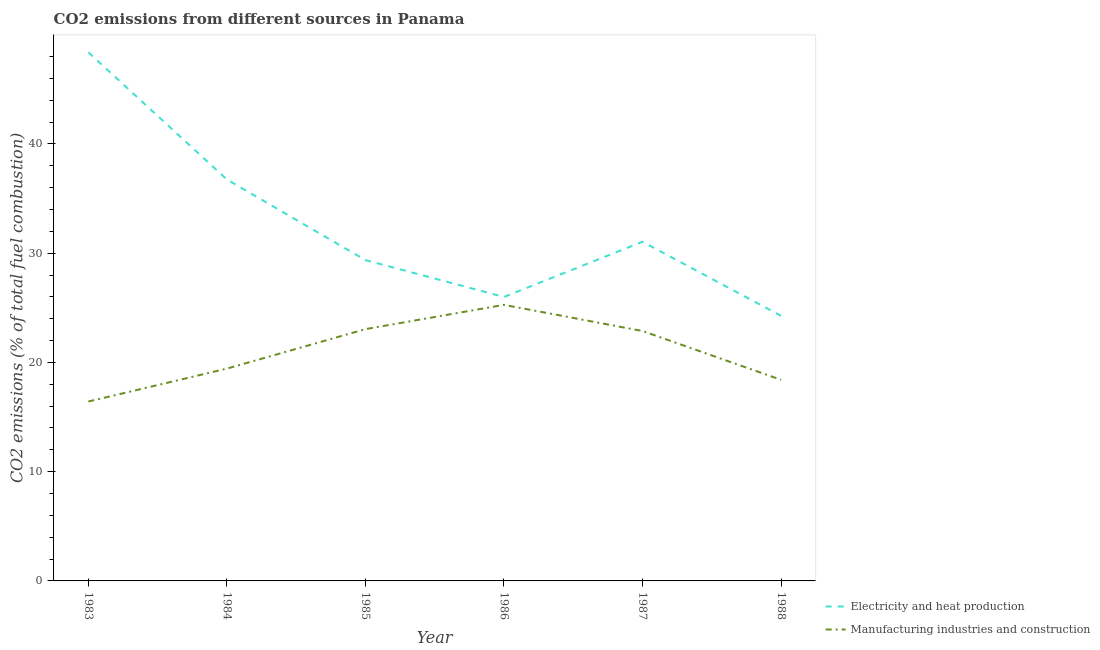Is the number of lines equal to the number of legend labels?
Provide a short and direct response. Yes. What is the co2 emissions due to manufacturing industries in 1987?
Provide a short and direct response. 22.88. Across all years, what is the maximum co2 emissions due to manufacturing industries?
Make the answer very short. 25.27. Across all years, what is the minimum co2 emissions due to manufacturing industries?
Offer a very short reply. 16.42. In which year was the co2 emissions due to electricity and heat production minimum?
Make the answer very short. 1988. What is the total co2 emissions due to electricity and heat production in the graph?
Your response must be concise. 195.81. What is the difference between the co2 emissions due to electricity and heat production in 1984 and that in 1988?
Provide a succinct answer. 12.48. What is the difference between the co2 emissions due to electricity and heat production in 1988 and the co2 emissions due to manufacturing industries in 1987?
Keep it short and to the point. 1.39. What is the average co2 emissions due to manufacturing industries per year?
Ensure brevity in your answer.  20.91. In the year 1986, what is the difference between the co2 emissions due to manufacturing industries and co2 emissions due to electricity and heat production?
Ensure brevity in your answer.  -0.72. What is the ratio of the co2 emissions due to manufacturing industries in 1987 to that in 1988?
Offer a very short reply. 1.24. Is the co2 emissions due to manufacturing industries in 1983 less than that in 1988?
Your answer should be compact. Yes. What is the difference between the highest and the second highest co2 emissions due to manufacturing industries?
Offer a very short reply. 2.22. What is the difference between the highest and the lowest co2 emissions due to electricity and heat production?
Offer a terse response. 24.12. In how many years, is the co2 emissions due to electricity and heat production greater than the average co2 emissions due to electricity and heat production taken over all years?
Ensure brevity in your answer.  2. How many years are there in the graph?
Offer a terse response. 6. Does the graph contain any zero values?
Your response must be concise. No. Does the graph contain grids?
Keep it short and to the point. No. How many legend labels are there?
Ensure brevity in your answer.  2. What is the title of the graph?
Offer a terse response. CO2 emissions from different sources in Panama. What is the label or title of the Y-axis?
Give a very brief answer. CO2 emissions (% of total fuel combustion). What is the CO2 emissions (% of total fuel combustion) of Electricity and heat production in 1983?
Provide a short and direct response. 48.39. What is the CO2 emissions (% of total fuel combustion) in Manufacturing industries and construction in 1983?
Your answer should be compact. 16.42. What is the CO2 emissions (% of total fuel combustion) of Electricity and heat production in 1984?
Make the answer very short. 36.75. What is the CO2 emissions (% of total fuel combustion) in Manufacturing industries and construction in 1984?
Your response must be concise. 19.43. What is the CO2 emissions (% of total fuel combustion) in Electricity and heat production in 1985?
Provide a succinct answer. 29.37. What is the CO2 emissions (% of total fuel combustion) of Manufacturing industries and construction in 1985?
Give a very brief answer. 23.05. What is the CO2 emissions (% of total fuel combustion) of Electricity and heat production in 1986?
Ensure brevity in your answer.  25.99. What is the CO2 emissions (% of total fuel combustion) of Manufacturing industries and construction in 1986?
Offer a terse response. 25.27. What is the CO2 emissions (% of total fuel combustion) in Electricity and heat production in 1987?
Offer a terse response. 31.05. What is the CO2 emissions (% of total fuel combustion) in Manufacturing industries and construction in 1987?
Offer a very short reply. 22.88. What is the CO2 emissions (% of total fuel combustion) of Electricity and heat production in 1988?
Your answer should be very brief. 24.27. What is the CO2 emissions (% of total fuel combustion) of Manufacturing industries and construction in 1988?
Keep it short and to the point. 18.41. Across all years, what is the maximum CO2 emissions (% of total fuel combustion) of Electricity and heat production?
Ensure brevity in your answer.  48.39. Across all years, what is the maximum CO2 emissions (% of total fuel combustion) in Manufacturing industries and construction?
Provide a short and direct response. 25.27. Across all years, what is the minimum CO2 emissions (% of total fuel combustion) of Electricity and heat production?
Keep it short and to the point. 24.27. Across all years, what is the minimum CO2 emissions (% of total fuel combustion) in Manufacturing industries and construction?
Offer a terse response. 16.42. What is the total CO2 emissions (% of total fuel combustion) of Electricity and heat production in the graph?
Your answer should be compact. 195.81. What is the total CO2 emissions (% of total fuel combustion) of Manufacturing industries and construction in the graph?
Keep it short and to the point. 125.46. What is the difference between the CO2 emissions (% of total fuel combustion) of Electricity and heat production in 1983 and that in 1984?
Offer a terse response. 11.64. What is the difference between the CO2 emissions (% of total fuel combustion) in Manufacturing industries and construction in 1983 and that in 1984?
Give a very brief answer. -3.01. What is the difference between the CO2 emissions (% of total fuel combustion) in Electricity and heat production in 1983 and that in 1985?
Keep it short and to the point. 19.02. What is the difference between the CO2 emissions (% of total fuel combustion) in Manufacturing industries and construction in 1983 and that in 1985?
Your answer should be compact. -6.63. What is the difference between the CO2 emissions (% of total fuel combustion) in Electricity and heat production in 1983 and that in 1986?
Ensure brevity in your answer.  22.39. What is the difference between the CO2 emissions (% of total fuel combustion) in Manufacturing industries and construction in 1983 and that in 1986?
Provide a short and direct response. -8.85. What is the difference between the CO2 emissions (% of total fuel combustion) in Electricity and heat production in 1983 and that in 1987?
Your response must be concise. 17.34. What is the difference between the CO2 emissions (% of total fuel combustion) in Manufacturing industries and construction in 1983 and that in 1987?
Offer a terse response. -6.45. What is the difference between the CO2 emissions (% of total fuel combustion) of Electricity and heat production in 1983 and that in 1988?
Offer a very short reply. 24.12. What is the difference between the CO2 emissions (% of total fuel combustion) of Manufacturing industries and construction in 1983 and that in 1988?
Ensure brevity in your answer.  -1.99. What is the difference between the CO2 emissions (% of total fuel combustion) of Electricity and heat production in 1984 and that in 1985?
Ensure brevity in your answer.  7.38. What is the difference between the CO2 emissions (% of total fuel combustion) of Manufacturing industries and construction in 1984 and that in 1985?
Give a very brief answer. -3.61. What is the difference between the CO2 emissions (% of total fuel combustion) of Electricity and heat production in 1984 and that in 1986?
Make the answer very short. 10.76. What is the difference between the CO2 emissions (% of total fuel combustion) of Manufacturing industries and construction in 1984 and that in 1986?
Your answer should be compact. -5.84. What is the difference between the CO2 emissions (% of total fuel combustion) of Electricity and heat production in 1984 and that in 1987?
Give a very brief answer. 5.7. What is the difference between the CO2 emissions (% of total fuel combustion) in Manufacturing industries and construction in 1984 and that in 1987?
Give a very brief answer. -3.44. What is the difference between the CO2 emissions (% of total fuel combustion) of Electricity and heat production in 1984 and that in 1988?
Provide a succinct answer. 12.48. What is the difference between the CO2 emissions (% of total fuel combustion) in Manufacturing industries and construction in 1984 and that in 1988?
Offer a very short reply. 1.02. What is the difference between the CO2 emissions (% of total fuel combustion) in Electricity and heat production in 1985 and that in 1986?
Provide a short and direct response. 3.38. What is the difference between the CO2 emissions (% of total fuel combustion) in Manufacturing industries and construction in 1985 and that in 1986?
Your response must be concise. -2.22. What is the difference between the CO2 emissions (% of total fuel combustion) in Electricity and heat production in 1985 and that in 1987?
Provide a short and direct response. -1.68. What is the difference between the CO2 emissions (% of total fuel combustion) of Manufacturing industries and construction in 1985 and that in 1987?
Provide a short and direct response. 0.17. What is the difference between the CO2 emissions (% of total fuel combustion) in Electricity and heat production in 1985 and that in 1988?
Make the answer very short. 5.1. What is the difference between the CO2 emissions (% of total fuel combustion) of Manufacturing industries and construction in 1985 and that in 1988?
Ensure brevity in your answer.  4.64. What is the difference between the CO2 emissions (% of total fuel combustion) of Electricity and heat production in 1986 and that in 1987?
Your answer should be compact. -5.05. What is the difference between the CO2 emissions (% of total fuel combustion) in Manufacturing industries and construction in 1986 and that in 1987?
Your answer should be compact. 2.39. What is the difference between the CO2 emissions (% of total fuel combustion) in Electricity and heat production in 1986 and that in 1988?
Your response must be concise. 1.73. What is the difference between the CO2 emissions (% of total fuel combustion) of Manufacturing industries and construction in 1986 and that in 1988?
Provide a short and direct response. 6.86. What is the difference between the CO2 emissions (% of total fuel combustion) in Electricity and heat production in 1987 and that in 1988?
Ensure brevity in your answer.  6.78. What is the difference between the CO2 emissions (% of total fuel combustion) of Manufacturing industries and construction in 1987 and that in 1988?
Give a very brief answer. 4.47. What is the difference between the CO2 emissions (% of total fuel combustion) of Electricity and heat production in 1983 and the CO2 emissions (% of total fuel combustion) of Manufacturing industries and construction in 1984?
Offer a terse response. 28.95. What is the difference between the CO2 emissions (% of total fuel combustion) of Electricity and heat production in 1983 and the CO2 emissions (% of total fuel combustion) of Manufacturing industries and construction in 1985?
Give a very brief answer. 25.34. What is the difference between the CO2 emissions (% of total fuel combustion) in Electricity and heat production in 1983 and the CO2 emissions (% of total fuel combustion) in Manufacturing industries and construction in 1986?
Keep it short and to the point. 23.12. What is the difference between the CO2 emissions (% of total fuel combustion) of Electricity and heat production in 1983 and the CO2 emissions (% of total fuel combustion) of Manufacturing industries and construction in 1987?
Make the answer very short. 25.51. What is the difference between the CO2 emissions (% of total fuel combustion) of Electricity and heat production in 1983 and the CO2 emissions (% of total fuel combustion) of Manufacturing industries and construction in 1988?
Make the answer very short. 29.98. What is the difference between the CO2 emissions (% of total fuel combustion) of Electricity and heat production in 1984 and the CO2 emissions (% of total fuel combustion) of Manufacturing industries and construction in 1985?
Ensure brevity in your answer.  13.7. What is the difference between the CO2 emissions (% of total fuel combustion) of Electricity and heat production in 1984 and the CO2 emissions (% of total fuel combustion) of Manufacturing industries and construction in 1986?
Provide a succinct answer. 11.48. What is the difference between the CO2 emissions (% of total fuel combustion) in Electricity and heat production in 1984 and the CO2 emissions (% of total fuel combustion) in Manufacturing industries and construction in 1987?
Make the answer very short. 13.87. What is the difference between the CO2 emissions (% of total fuel combustion) of Electricity and heat production in 1984 and the CO2 emissions (% of total fuel combustion) of Manufacturing industries and construction in 1988?
Provide a succinct answer. 18.34. What is the difference between the CO2 emissions (% of total fuel combustion) in Electricity and heat production in 1985 and the CO2 emissions (% of total fuel combustion) in Manufacturing industries and construction in 1986?
Provide a short and direct response. 4.1. What is the difference between the CO2 emissions (% of total fuel combustion) of Electricity and heat production in 1985 and the CO2 emissions (% of total fuel combustion) of Manufacturing industries and construction in 1987?
Offer a very short reply. 6.49. What is the difference between the CO2 emissions (% of total fuel combustion) in Electricity and heat production in 1985 and the CO2 emissions (% of total fuel combustion) in Manufacturing industries and construction in 1988?
Provide a succinct answer. 10.96. What is the difference between the CO2 emissions (% of total fuel combustion) of Electricity and heat production in 1986 and the CO2 emissions (% of total fuel combustion) of Manufacturing industries and construction in 1987?
Offer a very short reply. 3.12. What is the difference between the CO2 emissions (% of total fuel combustion) in Electricity and heat production in 1986 and the CO2 emissions (% of total fuel combustion) in Manufacturing industries and construction in 1988?
Your answer should be compact. 7.58. What is the difference between the CO2 emissions (% of total fuel combustion) of Electricity and heat production in 1987 and the CO2 emissions (% of total fuel combustion) of Manufacturing industries and construction in 1988?
Give a very brief answer. 12.64. What is the average CO2 emissions (% of total fuel combustion) of Electricity and heat production per year?
Your response must be concise. 32.64. What is the average CO2 emissions (% of total fuel combustion) in Manufacturing industries and construction per year?
Your answer should be very brief. 20.91. In the year 1983, what is the difference between the CO2 emissions (% of total fuel combustion) of Electricity and heat production and CO2 emissions (% of total fuel combustion) of Manufacturing industries and construction?
Your answer should be very brief. 31.96. In the year 1984, what is the difference between the CO2 emissions (% of total fuel combustion) of Electricity and heat production and CO2 emissions (% of total fuel combustion) of Manufacturing industries and construction?
Keep it short and to the point. 17.31. In the year 1985, what is the difference between the CO2 emissions (% of total fuel combustion) of Electricity and heat production and CO2 emissions (% of total fuel combustion) of Manufacturing industries and construction?
Keep it short and to the point. 6.32. In the year 1986, what is the difference between the CO2 emissions (% of total fuel combustion) of Electricity and heat production and CO2 emissions (% of total fuel combustion) of Manufacturing industries and construction?
Give a very brief answer. 0.72. In the year 1987, what is the difference between the CO2 emissions (% of total fuel combustion) of Electricity and heat production and CO2 emissions (% of total fuel combustion) of Manufacturing industries and construction?
Give a very brief answer. 8.17. In the year 1988, what is the difference between the CO2 emissions (% of total fuel combustion) of Electricity and heat production and CO2 emissions (% of total fuel combustion) of Manufacturing industries and construction?
Your answer should be compact. 5.86. What is the ratio of the CO2 emissions (% of total fuel combustion) in Electricity and heat production in 1983 to that in 1984?
Give a very brief answer. 1.32. What is the ratio of the CO2 emissions (% of total fuel combustion) in Manufacturing industries and construction in 1983 to that in 1984?
Ensure brevity in your answer.  0.84. What is the ratio of the CO2 emissions (% of total fuel combustion) in Electricity and heat production in 1983 to that in 1985?
Give a very brief answer. 1.65. What is the ratio of the CO2 emissions (% of total fuel combustion) of Manufacturing industries and construction in 1983 to that in 1985?
Your response must be concise. 0.71. What is the ratio of the CO2 emissions (% of total fuel combustion) of Electricity and heat production in 1983 to that in 1986?
Your response must be concise. 1.86. What is the ratio of the CO2 emissions (% of total fuel combustion) of Manufacturing industries and construction in 1983 to that in 1986?
Ensure brevity in your answer.  0.65. What is the ratio of the CO2 emissions (% of total fuel combustion) in Electricity and heat production in 1983 to that in 1987?
Your answer should be compact. 1.56. What is the ratio of the CO2 emissions (% of total fuel combustion) of Manufacturing industries and construction in 1983 to that in 1987?
Provide a short and direct response. 0.72. What is the ratio of the CO2 emissions (% of total fuel combustion) in Electricity and heat production in 1983 to that in 1988?
Provide a succinct answer. 1.99. What is the ratio of the CO2 emissions (% of total fuel combustion) in Manufacturing industries and construction in 1983 to that in 1988?
Ensure brevity in your answer.  0.89. What is the ratio of the CO2 emissions (% of total fuel combustion) in Electricity and heat production in 1984 to that in 1985?
Your response must be concise. 1.25. What is the ratio of the CO2 emissions (% of total fuel combustion) in Manufacturing industries and construction in 1984 to that in 1985?
Provide a succinct answer. 0.84. What is the ratio of the CO2 emissions (% of total fuel combustion) in Electricity and heat production in 1984 to that in 1986?
Give a very brief answer. 1.41. What is the ratio of the CO2 emissions (% of total fuel combustion) of Manufacturing industries and construction in 1984 to that in 1986?
Keep it short and to the point. 0.77. What is the ratio of the CO2 emissions (% of total fuel combustion) of Electricity and heat production in 1984 to that in 1987?
Your response must be concise. 1.18. What is the ratio of the CO2 emissions (% of total fuel combustion) of Manufacturing industries and construction in 1984 to that in 1987?
Give a very brief answer. 0.85. What is the ratio of the CO2 emissions (% of total fuel combustion) of Electricity and heat production in 1984 to that in 1988?
Make the answer very short. 1.51. What is the ratio of the CO2 emissions (% of total fuel combustion) in Manufacturing industries and construction in 1984 to that in 1988?
Give a very brief answer. 1.06. What is the ratio of the CO2 emissions (% of total fuel combustion) of Electricity and heat production in 1985 to that in 1986?
Your response must be concise. 1.13. What is the ratio of the CO2 emissions (% of total fuel combustion) of Manufacturing industries and construction in 1985 to that in 1986?
Provide a succinct answer. 0.91. What is the ratio of the CO2 emissions (% of total fuel combustion) in Electricity and heat production in 1985 to that in 1987?
Give a very brief answer. 0.95. What is the ratio of the CO2 emissions (% of total fuel combustion) of Manufacturing industries and construction in 1985 to that in 1987?
Offer a terse response. 1.01. What is the ratio of the CO2 emissions (% of total fuel combustion) of Electricity and heat production in 1985 to that in 1988?
Make the answer very short. 1.21. What is the ratio of the CO2 emissions (% of total fuel combustion) of Manufacturing industries and construction in 1985 to that in 1988?
Make the answer very short. 1.25. What is the ratio of the CO2 emissions (% of total fuel combustion) in Electricity and heat production in 1986 to that in 1987?
Keep it short and to the point. 0.84. What is the ratio of the CO2 emissions (% of total fuel combustion) of Manufacturing industries and construction in 1986 to that in 1987?
Offer a very short reply. 1.1. What is the ratio of the CO2 emissions (% of total fuel combustion) in Electricity and heat production in 1986 to that in 1988?
Give a very brief answer. 1.07. What is the ratio of the CO2 emissions (% of total fuel combustion) of Manufacturing industries and construction in 1986 to that in 1988?
Keep it short and to the point. 1.37. What is the ratio of the CO2 emissions (% of total fuel combustion) in Electricity and heat production in 1987 to that in 1988?
Keep it short and to the point. 1.28. What is the ratio of the CO2 emissions (% of total fuel combustion) of Manufacturing industries and construction in 1987 to that in 1988?
Your answer should be compact. 1.24. What is the difference between the highest and the second highest CO2 emissions (% of total fuel combustion) of Electricity and heat production?
Provide a succinct answer. 11.64. What is the difference between the highest and the second highest CO2 emissions (% of total fuel combustion) in Manufacturing industries and construction?
Give a very brief answer. 2.22. What is the difference between the highest and the lowest CO2 emissions (% of total fuel combustion) of Electricity and heat production?
Give a very brief answer. 24.12. What is the difference between the highest and the lowest CO2 emissions (% of total fuel combustion) of Manufacturing industries and construction?
Make the answer very short. 8.85. 